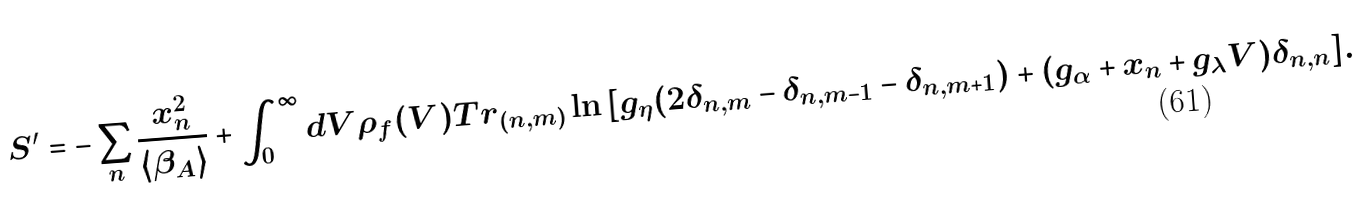Convert formula to latex. <formula><loc_0><loc_0><loc_500><loc_500>S ^ { \prime } = - \sum _ { n } \frac { x _ { n } ^ { 2 } } { \langle \beta _ { A } \rangle } + \int _ { 0 } ^ { \infty } d V \rho _ { f } ( V ) T r _ { ( n , m ) } \ln { \left [ g _ { \eta } ( 2 \delta _ { n , m } - \delta _ { n , m - 1 } - \delta _ { n , m + 1 } ) + ( g _ { \alpha } + x _ { n } + g _ { \lambda } V ) \delta _ { n , n } \right ] } .</formula> 